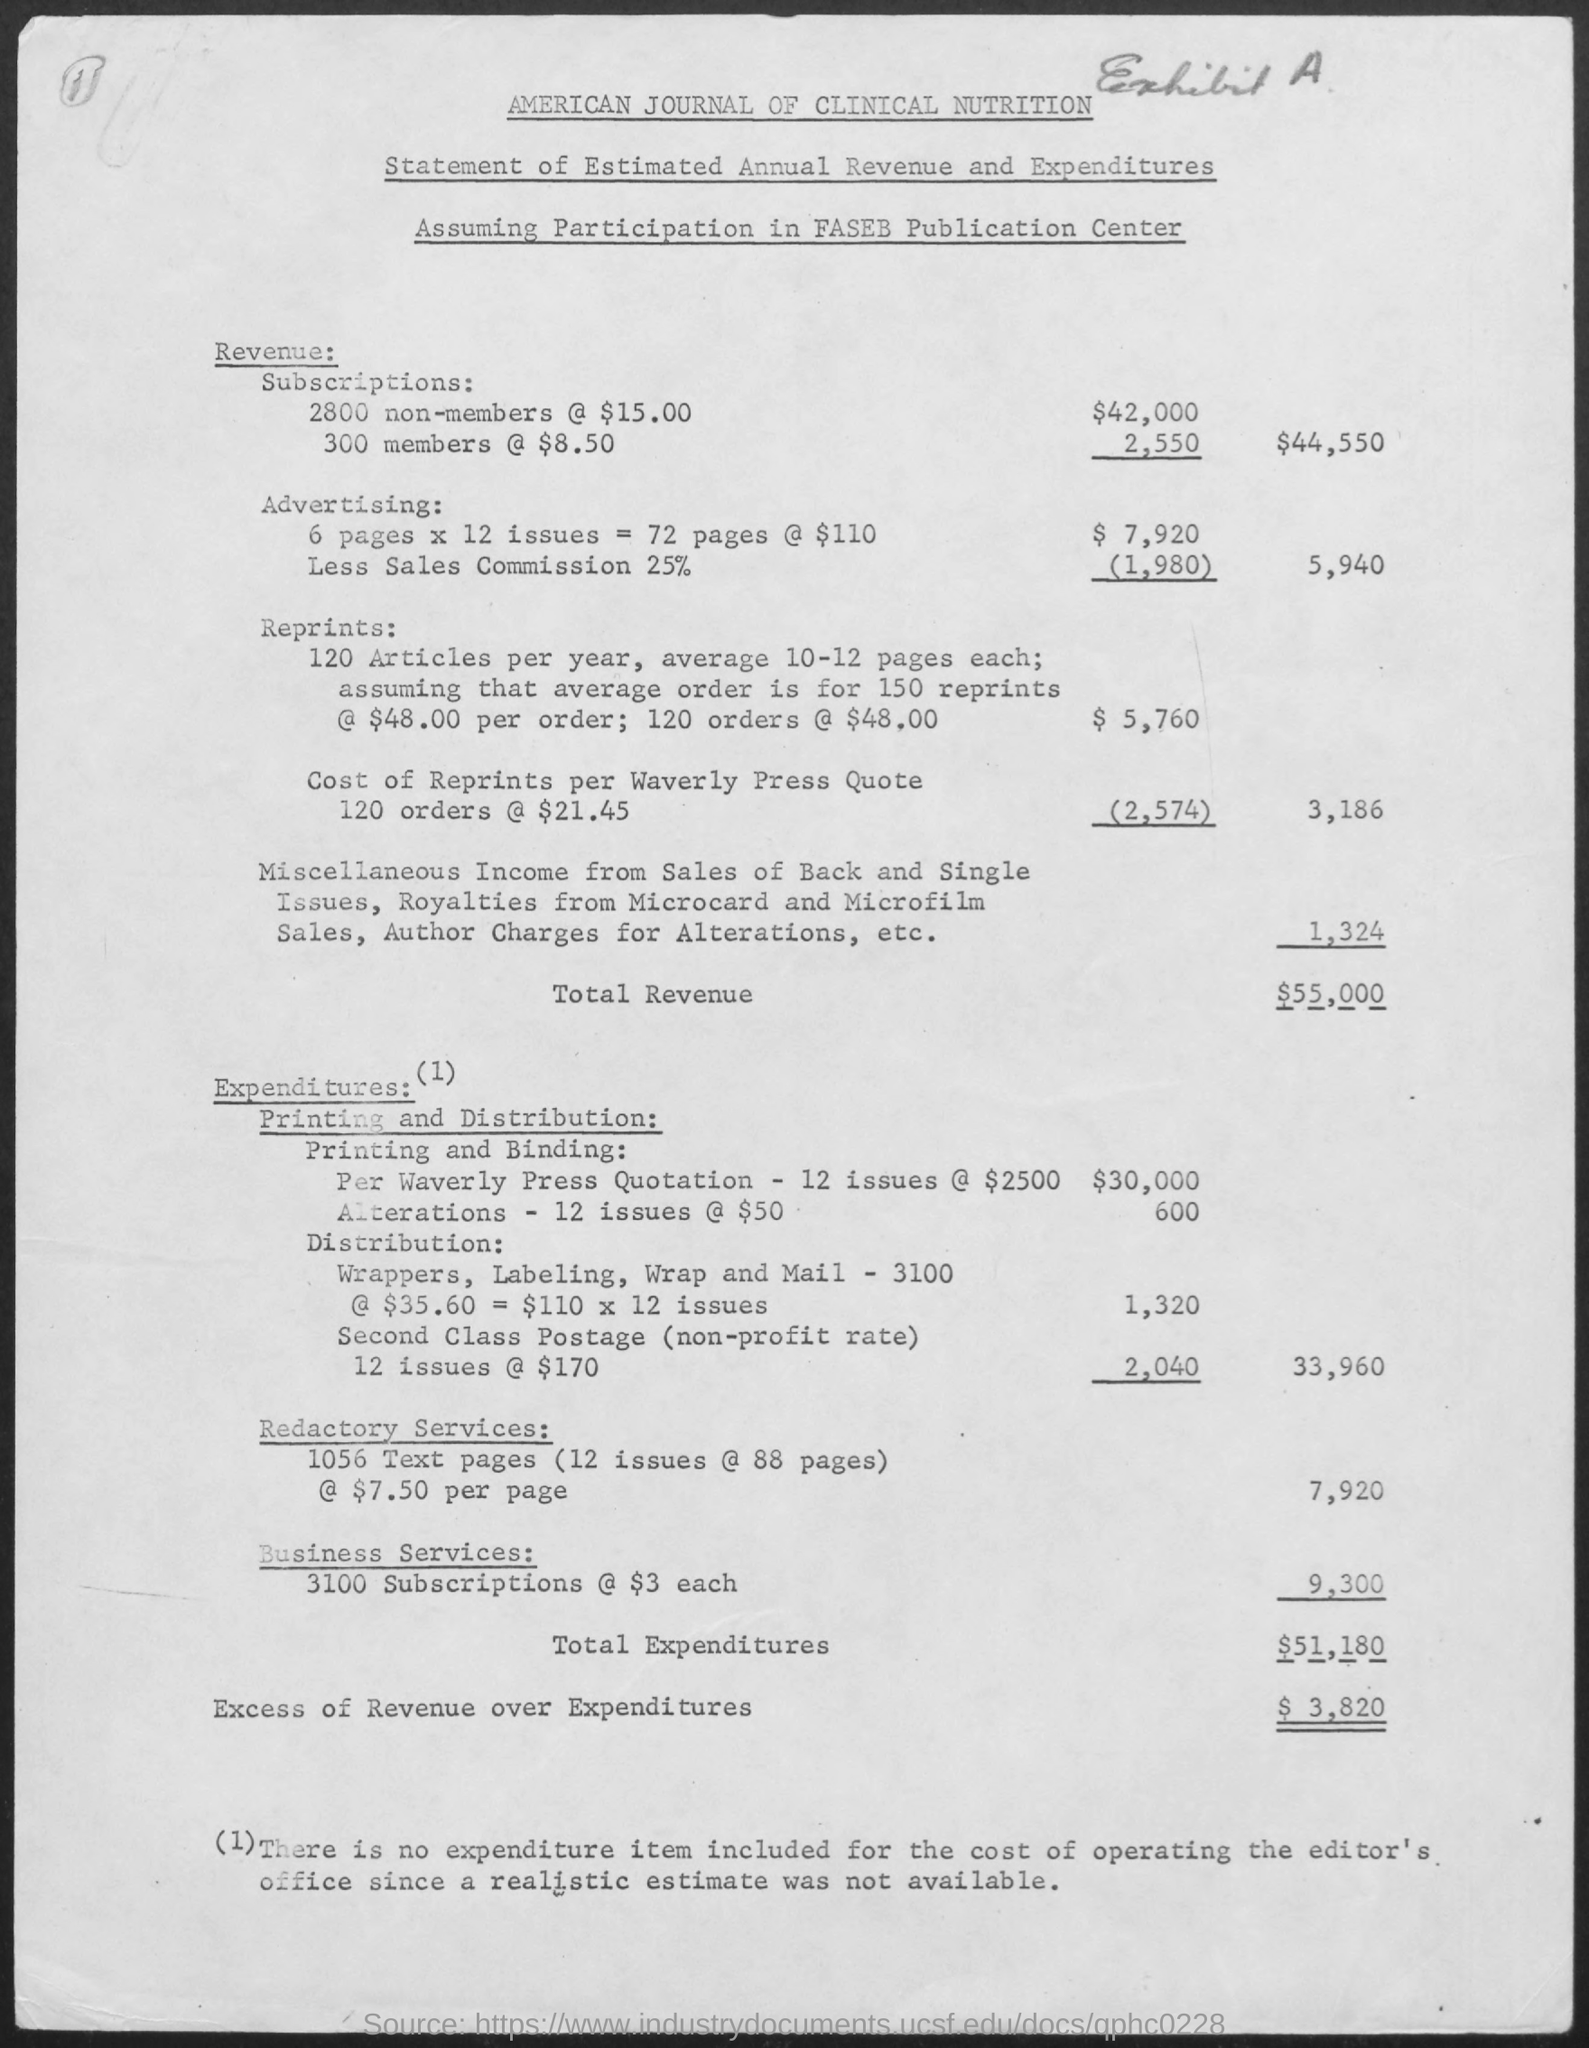Point out several critical features in this image. The total expenditures for the current fiscal year are $51,180. The total revenue is 55,000. The excess of revenue over expenditures is 3,280. 